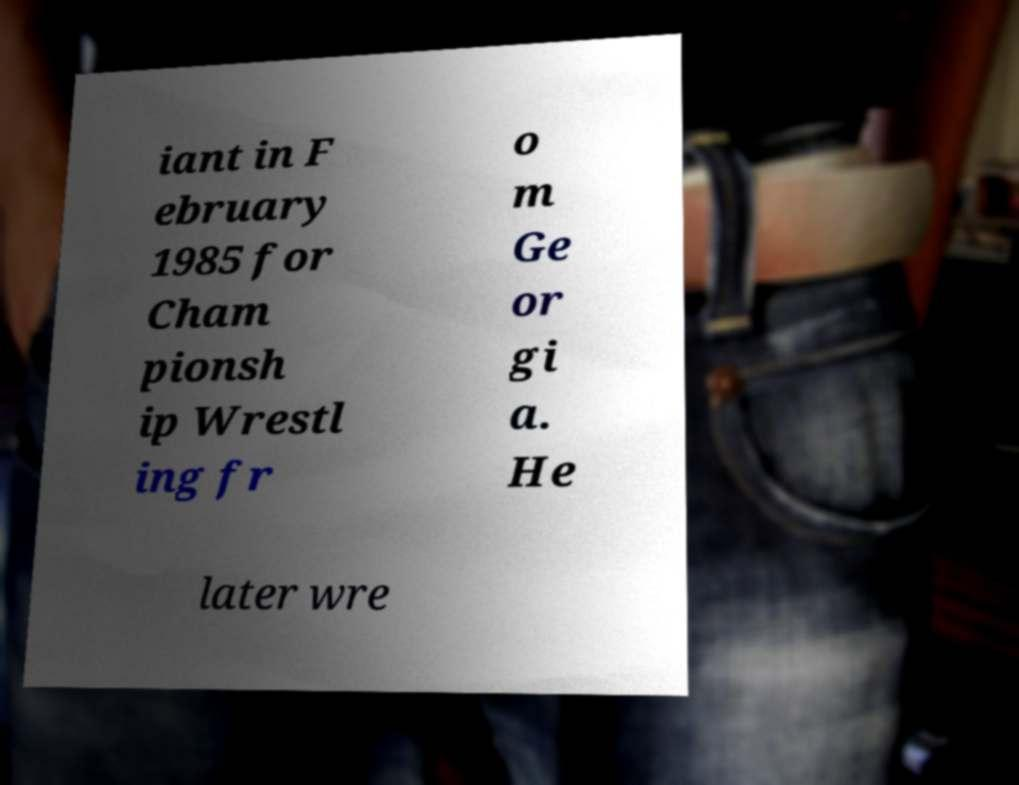For documentation purposes, I need the text within this image transcribed. Could you provide that? iant in F ebruary 1985 for Cham pionsh ip Wrestl ing fr o m Ge or gi a. He later wre 